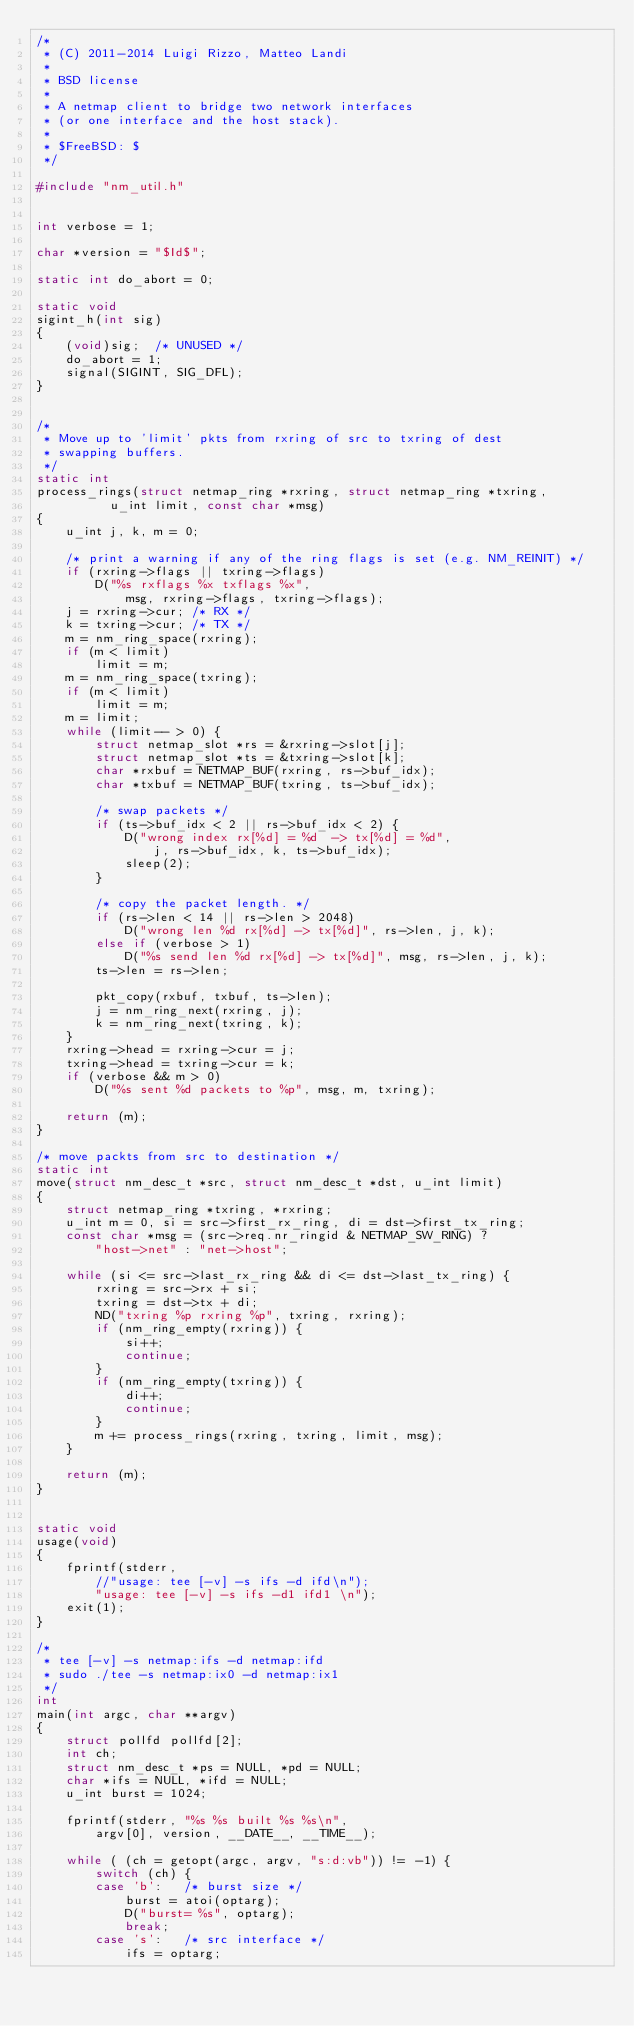Convert code to text. <code><loc_0><loc_0><loc_500><loc_500><_C_>/*
 * (C) 2011-2014 Luigi Rizzo, Matteo Landi
 *
 * BSD license
 *
 * A netmap client to bridge two network interfaces
 * (or one interface and the host stack).
 *
 * $FreeBSD: $
 */

#include "nm_util.h"


int verbose = 1;

char *version = "$Id$";

static int do_abort = 0;

static void
sigint_h(int sig)
{
	(void)sig;	/* UNUSED */
	do_abort = 1;
	signal(SIGINT, SIG_DFL);
}


/*
 * Move up to 'limit' pkts from rxring of src to txring of dest
 * swapping buffers.
 */
static int
process_rings(struct netmap_ring *rxring, struct netmap_ring *txring,
	      u_int limit, const char *msg)
{
	u_int j, k, m = 0;

	/* print a warning if any of the ring flags is set (e.g. NM_REINIT) */
	if (rxring->flags || txring->flags)
		D("%s rxflags %x txflags %x",
			msg, rxring->flags, txring->flags);
	j = rxring->cur; /* RX */
	k = txring->cur; /* TX */
	m = nm_ring_space(rxring);
	if (m < limit)
		limit = m;
	m = nm_ring_space(txring);
	if (m < limit)
		limit = m;
	m = limit;
	while (limit-- > 0) {
		struct netmap_slot *rs = &rxring->slot[j];
		struct netmap_slot *ts = &txring->slot[k];
		char *rxbuf = NETMAP_BUF(rxring, rs->buf_idx);
		char *txbuf = NETMAP_BUF(txring, ts->buf_idx);

		/* swap packets */
		if (ts->buf_idx < 2 || rs->buf_idx < 2) {
			D("wrong index rx[%d] = %d  -> tx[%d] = %d",
				j, rs->buf_idx, k, ts->buf_idx);
			sleep(2);
		}

		/* copy the packet length. */
		if (rs->len < 14 || rs->len > 2048)
			D("wrong len %d rx[%d] -> tx[%d]", rs->len, j, k);
		else if (verbose > 1)
			D("%s send len %d rx[%d] -> tx[%d]", msg, rs->len, j, k);
		ts->len = rs->len;

		pkt_copy(rxbuf, txbuf, ts->len);
		j = nm_ring_next(rxring, j);
		k = nm_ring_next(txring, k);
	}
	rxring->head = rxring->cur = j;
	txring->head = txring->cur = k;
	if (verbose && m > 0)
		D("%s sent %d packets to %p", msg, m, txring);

	return (m);
}

/* move packts from src to destination */
static int
move(struct nm_desc_t *src, struct nm_desc_t *dst, u_int limit)
{
	struct netmap_ring *txring, *rxring;
	u_int m = 0, si = src->first_rx_ring, di = dst->first_tx_ring;
	const char *msg = (src->req.nr_ringid & NETMAP_SW_RING) ?
		"host->net" : "net->host";

	while (si <= src->last_rx_ring && di <= dst->last_tx_ring) {
		rxring = src->rx + si;
		txring = dst->tx + di;
		ND("txring %p rxring %p", txring, rxring);
		if (nm_ring_empty(rxring)) {
			si++;
			continue;
		}
		if (nm_ring_empty(txring)) {
			di++;
			continue;
		}
		m += process_rings(rxring, txring, limit, msg);
	}

	return (m);
}


static void
usage(void)
{
	fprintf(stderr,
	    //"usage: tee [-v] -s ifs -d ifd\n");
	    "usage: tee [-v] -s ifs -d1 ifd1 \n");
	exit(1);
}

/*
 * tee [-v] -s netmap:ifs -d netmap:ifd
 * sudo ./tee -s netmap:ix0 -d netmap:ix1
 */
int
main(int argc, char **argv)
{
	struct pollfd pollfd[2];
	int ch;
	struct nm_desc_t *ps = NULL, *pd = NULL;
	char *ifs = NULL, *ifd = NULL;
	u_int burst = 1024;

	fprintf(stderr, "%s %s built %s %s\n",
		argv[0], version, __DATE__, __TIME__);

	while ( (ch = getopt(argc, argv, "s:d:vb")) != -1) {
		switch (ch) {
		case 'b':	/* burst size */
			burst = atoi(optarg);
			D("burst= %s", optarg);
			break;
		case 's':	/* src interface */
			ifs = optarg;</code> 